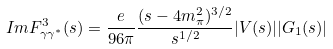Convert formula to latex. <formula><loc_0><loc_0><loc_500><loc_500>I m F _ { \gamma \gamma ^ { * } } ^ { 3 } ( s ) = \frac { e } { 9 6 \pi } \frac { ( s - 4 m _ { \pi } ^ { 2 } ) ^ { 3 / 2 } } { s ^ { 1 / 2 } } | V ( s ) | | G _ { 1 } ( s ) |</formula> 